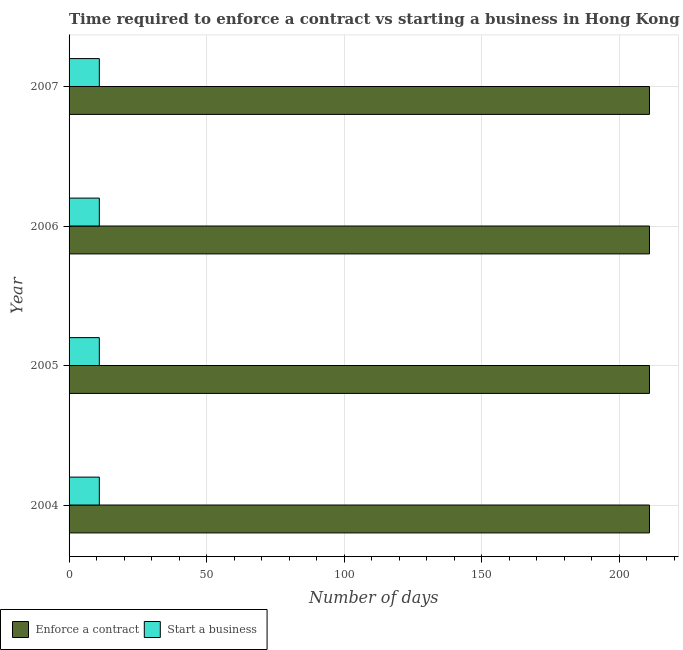How many different coloured bars are there?
Keep it short and to the point. 2. How many groups of bars are there?
Make the answer very short. 4. What is the label of the 3rd group of bars from the top?
Your response must be concise. 2005. In how many cases, is the number of bars for a given year not equal to the number of legend labels?
Give a very brief answer. 0. Across all years, what is the maximum number of days to start a business?
Keep it short and to the point. 11. Across all years, what is the minimum number of days to start a business?
Your answer should be very brief. 11. In which year was the number of days to enforece a contract maximum?
Give a very brief answer. 2004. In which year was the number of days to start a business minimum?
Offer a terse response. 2004. What is the total number of days to start a business in the graph?
Offer a terse response. 44. What is the difference between the number of days to enforece a contract in 2004 and that in 2005?
Your response must be concise. 0. In the year 2004, what is the difference between the number of days to start a business and number of days to enforece a contract?
Provide a short and direct response. -200. What is the ratio of the number of days to start a business in 2005 to that in 2006?
Provide a succinct answer. 1. Is the difference between the number of days to enforece a contract in 2004 and 2007 greater than the difference between the number of days to start a business in 2004 and 2007?
Your response must be concise. No. In how many years, is the number of days to enforece a contract greater than the average number of days to enforece a contract taken over all years?
Offer a very short reply. 0. Is the sum of the number of days to enforece a contract in 2006 and 2007 greater than the maximum number of days to start a business across all years?
Ensure brevity in your answer.  Yes. What does the 1st bar from the top in 2007 represents?
Offer a very short reply. Start a business. What does the 2nd bar from the bottom in 2007 represents?
Provide a short and direct response. Start a business. How many bars are there?
Your answer should be very brief. 8. Are all the bars in the graph horizontal?
Provide a succinct answer. Yes. Are the values on the major ticks of X-axis written in scientific E-notation?
Make the answer very short. No. Does the graph contain any zero values?
Provide a succinct answer. No. Does the graph contain grids?
Keep it short and to the point. Yes. What is the title of the graph?
Give a very brief answer. Time required to enforce a contract vs starting a business in Hong Kong. What is the label or title of the X-axis?
Make the answer very short. Number of days. What is the Number of days of Enforce a contract in 2004?
Keep it short and to the point. 211. What is the Number of days of Start a business in 2004?
Keep it short and to the point. 11. What is the Number of days of Enforce a contract in 2005?
Offer a very short reply. 211. What is the Number of days of Enforce a contract in 2006?
Give a very brief answer. 211. What is the Number of days of Enforce a contract in 2007?
Your response must be concise. 211. What is the Number of days in Start a business in 2007?
Offer a very short reply. 11. Across all years, what is the maximum Number of days in Enforce a contract?
Offer a very short reply. 211. Across all years, what is the maximum Number of days in Start a business?
Give a very brief answer. 11. Across all years, what is the minimum Number of days of Enforce a contract?
Your answer should be very brief. 211. What is the total Number of days in Enforce a contract in the graph?
Provide a succinct answer. 844. What is the difference between the Number of days of Enforce a contract in 2004 and that in 2005?
Offer a very short reply. 0. What is the difference between the Number of days of Start a business in 2004 and that in 2005?
Provide a short and direct response. 0. What is the difference between the Number of days in Enforce a contract in 2004 and that in 2006?
Offer a terse response. 0. What is the difference between the Number of days in Start a business in 2004 and that in 2006?
Offer a very short reply. 0. What is the difference between the Number of days in Start a business in 2004 and that in 2007?
Provide a succinct answer. 0. What is the difference between the Number of days of Enforce a contract in 2005 and that in 2006?
Give a very brief answer. 0. What is the difference between the Number of days in Enforce a contract in 2005 and that in 2007?
Offer a terse response. 0. What is the difference between the Number of days in Start a business in 2005 and that in 2007?
Offer a very short reply. 0. What is the difference between the Number of days in Enforce a contract in 2006 and that in 2007?
Your answer should be compact. 0. What is the difference between the Number of days of Enforce a contract in 2004 and the Number of days of Start a business in 2005?
Keep it short and to the point. 200. What is the difference between the Number of days of Enforce a contract in 2004 and the Number of days of Start a business in 2007?
Ensure brevity in your answer.  200. What is the difference between the Number of days in Enforce a contract in 2005 and the Number of days in Start a business in 2006?
Provide a succinct answer. 200. What is the difference between the Number of days of Enforce a contract in 2005 and the Number of days of Start a business in 2007?
Provide a short and direct response. 200. What is the average Number of days of Enforce a contract per year?
Offer a terse response. 211. In the year 2006, what is the difference between the Number of days in Enforce a contract and Number of days in Start a business?
Give a very brief answer. 200. What is the ratio of the Number of days in Enforce a contract in 2004 to that in 2005?
Keep it short and to the point. 1. What is the ratio of the Number of days in Start a business in 2004 to that in 2005?
Your answer should be compact. 1. What is the ratio of the Number of days in Enforce a contract in 2005 to that in 2007?
Your response must be concise. 1. What is the difference between the highest and the second highest Number of days of Enforce a contract?
Keep it short and to the point. 0. What is the difference between the highest and the second highest Number of days in Start a business?
Your response must be concise. 0. What is the difference between the highest and the lowest Number of days in Enforce a contract?
Offer a terse response. 0. What is the difference between the highest and the lowest Number of days of Start a business?
Keep it short and to the point. 0. 